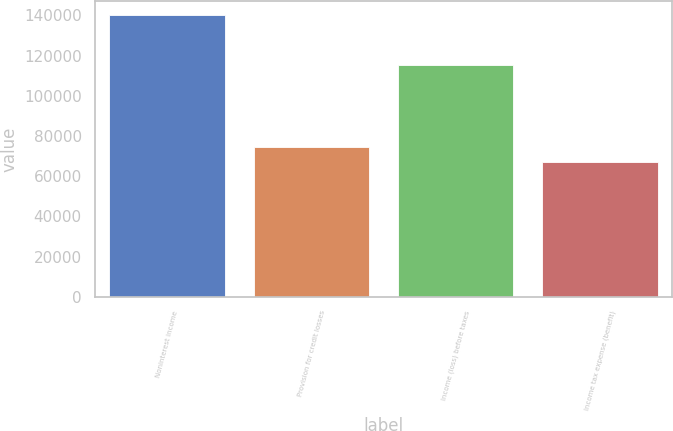<chart> <loc_0><loc_0><loc_500><loc_500><bar_chart><fcel>Noninterest income<fcel>Provision for credit losses<fcel>Income (loss) before taxes<fcel>Income tax expense (benefit)<nl><fcel>140063<fcel>74434.1<fcel>115207<fcel>67142<nl></chart> 